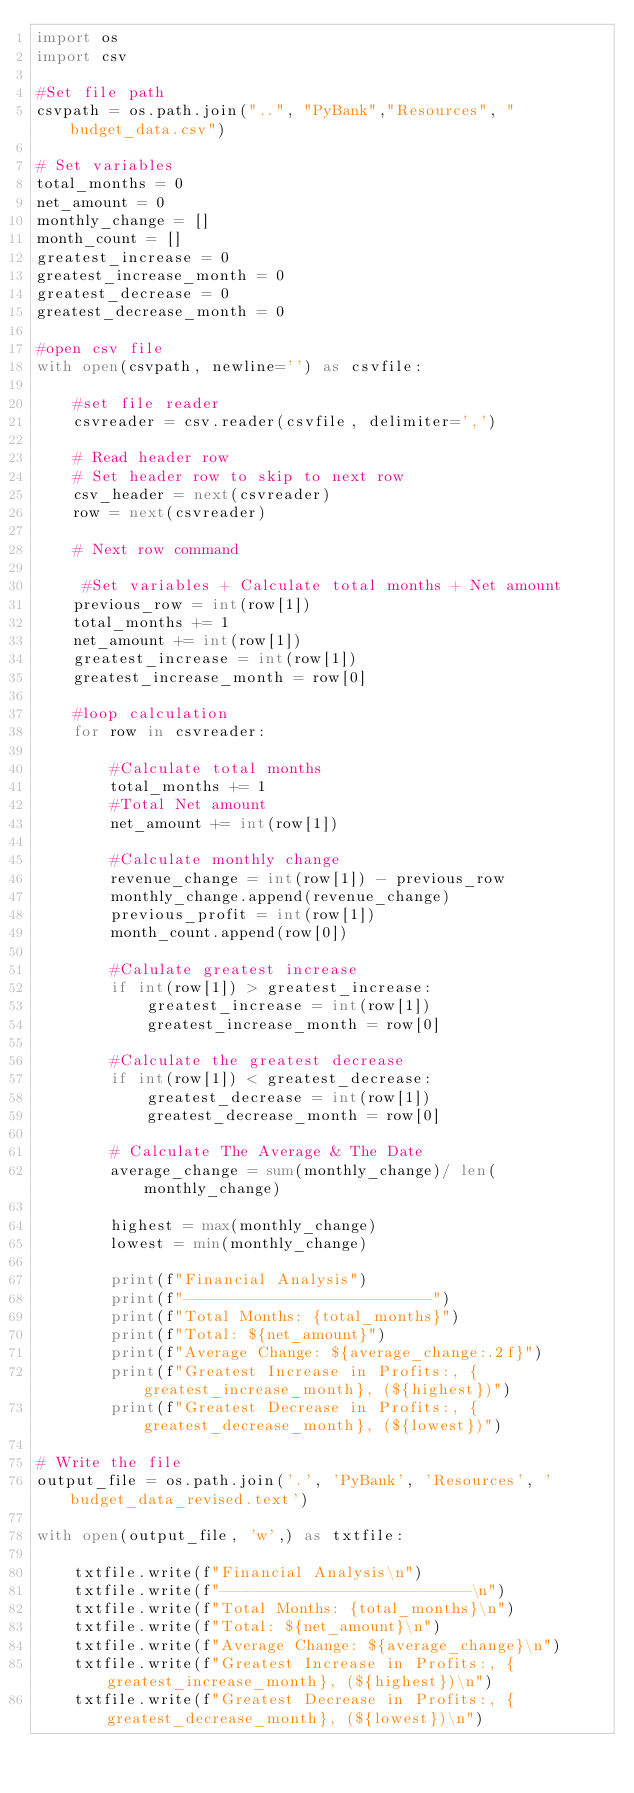Convert code to text. <code><loc_0><loc_0><loc_500><loc_500><_Python_>import os 
import csv

#Set file path
csvpath = os.path.join("..", "PyBank","Resources", "budget_data.csv")

# Set variables
total_months = 0 
net_amount = 0 
monthly_change = []
month_count = []
greatest_increase = 0 
greatest_increase_month = 0 
greatest_decrease = 0 
greatest_decrease_month = 0 

#open csv file 
with open(csvpath, newline='') as csvfile: 

    #set file reader 
    csvreader = csv.reader(csvfile, delimiter=',')

    # Read header row
    # Set header row to skip to next row 
    csv_header = next(csvreader)
    row = next(csvreader)

    # Next row command 

     #Set variables + Calculate total months + Net amount  
    previous_row = int(row[1])
    total_months += 1 
    net_amount += int(row[1])
    greatest_increase = int(row[1])
    greatest_increase_month = row[0]

    #loop calculation 
    for row in csvreader: 

        #Calculate total months 
        total_months += 1 
        #Total Net amount 
        net_amount += int(row[1])

        #Calculate monthly change 
        revenue_change = int(row[1]) - previous_row 
        monthly_change.append(revenue_change)
        previous_profit = int(row[1])
        month_count.append(row[0])

        #Calulate greatest increase 
        if int(row[1]) > greatest_increase:
            greatest_increase = int(row[1])
            greatest_increase_month = row[0]

        #Calculate the greatest decrease 
        if int(row[1]) < greatest_decrease:
            greatest_decrease = int(row[1])
            greatest_decrease_month = row[0]  

        # Calculate The Average & The Date
        average_change = sum(monthly_change)/ len(monthly_change)

        highest = max(monthly_change)
        lowest = min(monthly_change)

        print(f"Financial Analysis")
        print(f"---------------------------")
        print(f"Total Months: {total_months}")
        print(f"Total: ${net_amount}")
        print(f"Average Change: ${average_change:.2f}")
        print(f"Greatest Increase in Profits:, {greatest_increase_month}, (${highest})")
        print(f"Greatest Decrease in Profits:, {greatest_decrease_month}, (${lowest})")

# Write the file 
output_file = os.path.join('.', 'PyBank', 'Resources', 'budget_data_revised.text')

with open(output_file, 'w',) as txtfile:

    txtfile.write(f"Financial Analysis\n")
    txtfile.write(f"---------------------------\n")
    txtfile.write(f"Total Months: {total_months}\n")
    txtfile.write(f"Total: ${net_amount}\n")
    txtfile.write(f"Average Change: ${average_change}\n")
    txtfile.write(f"Greatest Increase in Profits:, {greatest_increase_month}, (${highest})\n")
    txtfile.write(f"Greatest Decrease in Profits:, {greatest_decrease_month}, (${lowest})\n")</code> 